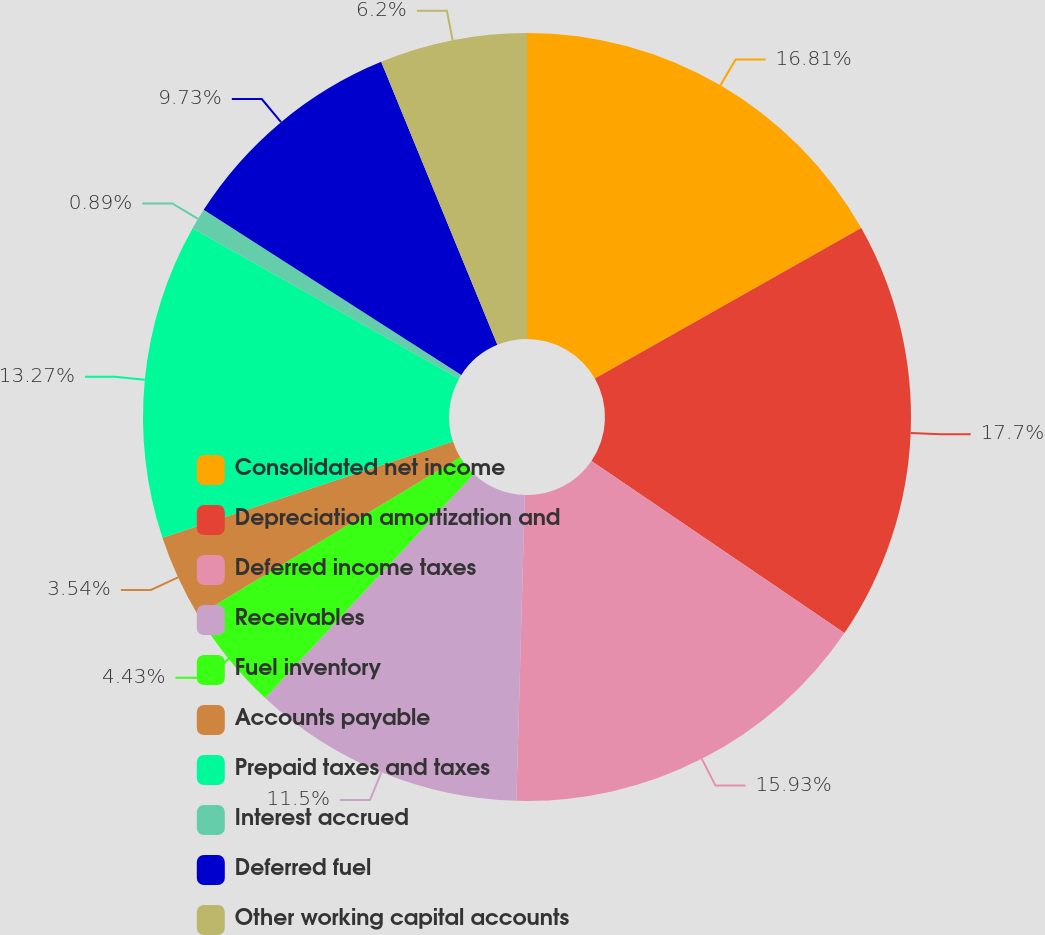Convert chart. <chart><loc_0><loc_0><loc_500><loc_500><pie_chart><fcel>Consolidated net income<fcel>Depreciation amortization and<fcel>Deferred income taxes<fcel>Receivables<fcel>Fuel inventory<fcel>Accounts payable<fcel>Prepaid taxes and taxes<fcel>Interest accrued<fcel>Deferred fuel<fcel>Other working capital accounts<nl><fcel>16.81%<fcel>17.7%<fcel>15.93%<fcel>11.5%<fcel>4.43%<fcel>3.54%<fcel>13.27%<fcel>0.89%<fcel>9.73%<fcel>6.2%<nl></chart> 